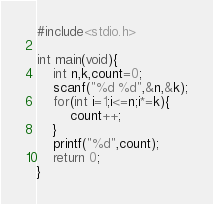Convert code to text. <code><loc_0><loc_0><loc_500><loc_500><_C_>#include<stdio.h>

int main(void){
    int n,k,count=0;
    scanf("%d %d",&n,&k);
    for(int i=1;i<=n;i*=k){
        count++;
    }
    printf("%d",count);
    return 0;
}</code> 